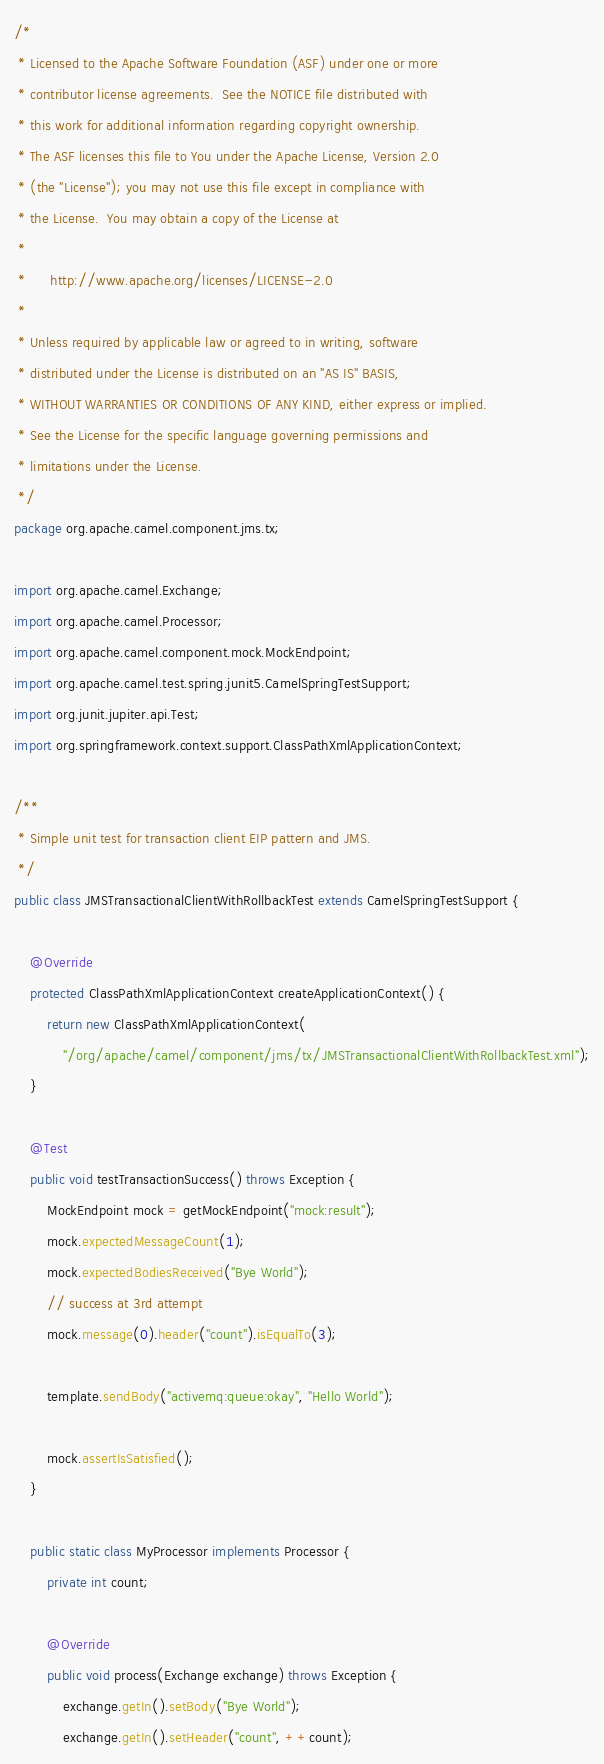Convert code to text. <code><loc_0><loc_0><loc_500><loc_500><_Java_>/*
 * Licensed to the Apache Software Foundation (ASF) under one or more
 * contributor license agreements.  See the NOTICE file distributed with
 * this work for additional information regarding copyright ownership.
 * The ASF licenses this file to You under the Apache License, Version 2.0
 * (the "License"); you may not use this file except in compliance with
 * the License.  You may obtain a copy of the License at
 *
 *      http://www.apache.org/licenses/LICENSE-2.0
 *
 * Unless required by applicable law or agreed to in writing, software
 * distributed under the License is distributed on an "AS IS" BASIS,
 * WITHOUT WARRANTIES OR CONDITIONS OF ANY KIND, either express or implied.
 * See the License for the specific language governing permissions and
 * limitations under the License.
 */
package org.apache.camel.component.jms.tx;

import org.apache.camel.Exchange;
import org.apache.camel.Processor;
import org.apache.camel.component.mock.MockEndpoint;
import org.apache.camel.test.spring.junit5.CamelSpringTestSupport;
import org.junit.jupiter.api.Test;
import org.springframework.context.support.ClassPathXmlApplicationContext;

/**
 * Simple unit test for transaction client EIP pattern and JMS.
 */
public class JMSTransactionalClientWithRollbackTest extends CamelSpringTestSupport {

    @Override
    protected ClassPathXmlApplicationContext createApplicationContext() {
        return new ClassPathXmlApplicationContext(
            "/org/apache/camel/component/jms/tx/JMSTransactionalClientWithRollbackTest.xml");
    }

    @Test
    public void testTransactionSuccess() throws Exception {
        MockEndpoint mock = getMockEndpoint("mock:result");
        mock.expectedMessageCount(1);
        mock.expectedBodiesReceived("Bye World");
        // success at 3rd attempt
        mock.message(0).header("count").isEqualTo(3);

        template.sendBody("activemq:queue:okay", "Hello World");

        mock.assertIsSatisfied();
    }

    public static class MyProcessor implements Processor {
        private int count;

        @Override
        public void process(Exchange exchange) throws Exception {
            exchange.getIn().setBody("Bye World");
            exchange.getIn().setHeader("count", ++count);</code> 